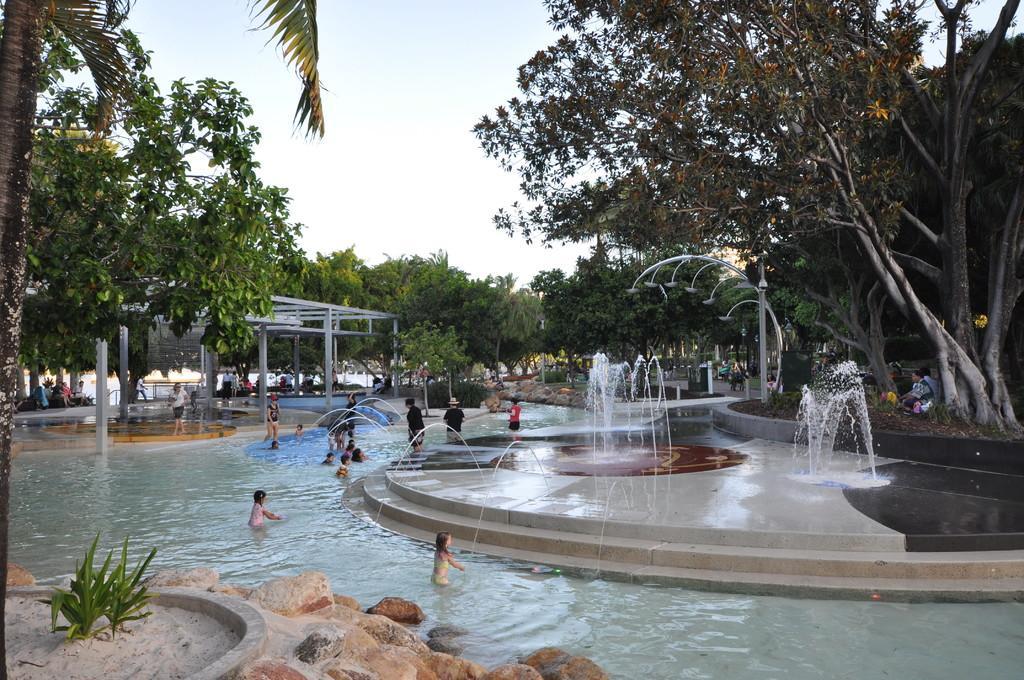In one or two sentences, can you explain what this image depicts? In this image we can see people playing in the pool, fountains, street poles, street lights, persons sitting on the benches, persons standing on the floor, trees, shrubs, stones and sky with clouds. 